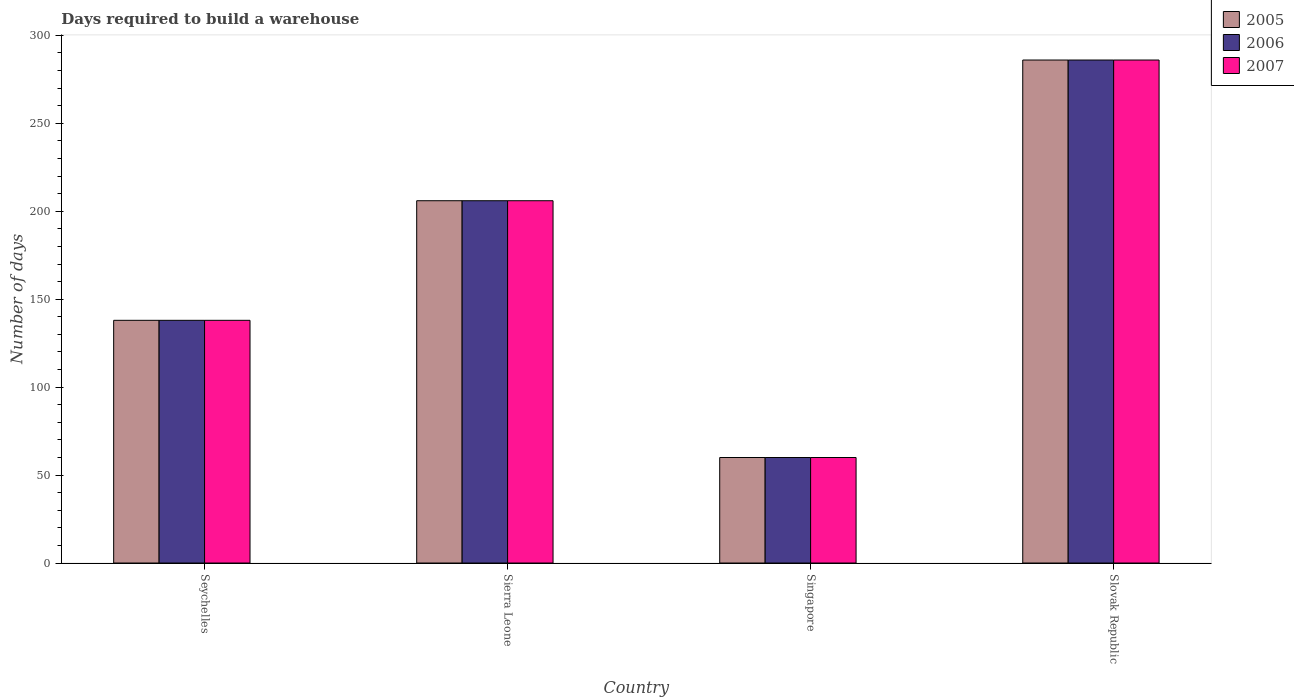How many different coloured bars are there?
Offer a very short reply. 3. Are the number of bars per tick equal to the number of legend labels?
Your answer should be very brief. Yes. What is the label of the 1st group of bars from the left?
Give a very brief answer. Seychelles. What is the days required to build a warehouse in in 2006 in Seychelles?
Your answer should be compact. 138. Across all countries, what is the maximum days required to build a warehouse in in 2007?
Make the answer very short. 286. In which country was the days required to build a warehouse in in 2007 maximum?
Make the answer very short. Slovak Republic. In which country was the days required to build a warehouse in in 2005 minimum?
Make the answer very short. Singapore. What is the total days required to build a warehouse in in 2005 in the graph?
Provide a short and direct response. 690. What is the difference between the days required to build a warehouse in in 2007 in Sierra Leone and that in Slovak Republic?
Offer a terse response. -80. What is the difference between the days required to build a warehouse in in 2006 in Slovak Republic and the days required to build a warehouse in in 2005 in Sierra Leone?
Offer a very short reply. 80. What is the average days required to build a warehouse in in 2005 per country?
Your response must be concise. 172.5. What is the difference between the days required to build a warehouse in of/in 2005 and days required to build a warehouse in of/in 2007 in Singapore?
Your response must be concise. 0. In how many countries, is the days required to build a warehouse in in 2007 greater than 180 days?
Your answer should be very brief. 2. What is the ratio of the days required to build a warehouse in in 2007 in Sierra Leone to that in Singapore?
Your answer should be very brief. 3.43. Is the days required to build a warehouse in in 2006 in Seychelles less than that in Slovak Republic?
Offer a terse response. Yes. What is the difference between the highest and the second highest days required to build a warehouse in in 2006?
Ensure brevity in your answer.  -68. What is the difference between the highest and the lowest days required to build a warehouse in in 2005?
Offer a terse response. 226. What does the 3rd bar from the left in Sierra Leone represents?
Your answer should be compact. 2007. What does the 3rd bar from the right in Sierra Leone represents?
Provide a succinct answer. 2005. Are all the bars in the graph horizontal?
Your answer should be very brief. No. What is the difference between two consecutive major ticks on the Y-axis?
Ensure brevity in your answer.  50. Does the graph contain grids?
Your response must be concise. No. Where does the legend appear in the graph?
Your response must be concise. Top right. What is the title of the graph?
Your response must be concise. Days required to build a warehouse. Does "1992" appear as one of the legend labels in the graph?
Provide a short and direct response. No. What is the label or title of the X-axis?
Make the answer very short. Country. What is the label or title of the Y-axis?
Provide a short and direct response. Number of days. What is the Number of days in 2005 in Seychelles?
Give a very brief answer. 138. What is the Number of days in 2006 in Seychelles?
Ensure brevity in your answer.  138. What is the Number of days of 2007 in Seychelles?
Your answer should be compact. 138. What is the Number of days in 2005 in Sierra Leone?
Provide a succinct answer. 206. What is the Number of days in 2006 in Sierra Leone?
Provide a succinct answer. 206. What is the Number of days of 2007 in Sierra Leone?
Offer a terse response. 206. What is the Number of days of 2005 in Singapore?
Give a very brief answer. 60. What is the Number of days of 2006 in Singapore?
Your answer should be compact. 60. What is the Number of days of 2007 in Singapore?
Your answer should be very brief. 60. What is the Number of days of 2005 in Slovak Republic?
Provide a short and direct response. 286. What is the Number of days of 2006 in Slovak Republic?
Ensure brevity in your answer.  286. What is the Number of days in 2007 in Slovak Republic?
Ensure brevity in your answer.  286. Across all countries, what is the maximum Number of days of 2005?
Make the answer very short. 286. Across all countries, what is the maximum Number of days in 2006?
Offer a very short reply. 286. Across all countries, what is the maximum Number of days in 2007?
Provide a succinct answer. 286. Across all countries, what is the minimum Number of days of 2006?
Your answer should be very brief. 60. What is the total Number of days in 2005 in the graph?
Provide a short and direct response. 690. What is the total Number of days in 2006 in the graph?
Give a very brief answer. 690. What is the total Number of days of 2007 in the graph?
Keep it short and to the point. 690. What is the difference between the Number of days of 2005 in Seychelles and that in Sierra Leone?
Offer a terse response. -68. What is the difference between the Number of days of 2006 in Seychelles and that in Sierra Leone?
Your response must be concise. -68. What is the difference between the Number of days in 2007 in Seychelles and that in Sierra Leone?
Make the answer very short. -68. What is the difference between the Number of days in 2005 in Seychelles and that in Slovak Republic?
Give a very brief answer. -148. What is the difference between the Number of days of 2006 in Seychelles and that in Slovak Republic?
Offer a terse response. -148. What is the difference between the Number of days of 2007 in Seychelles and that in Slovak Republic?
Your answer should be very brief. -148. What is the difference between the Number of days of 2005 in Sierra Leone and that in Singapore?
Your answer should be compact. 146. What is the difference between the Number of days of 2006 in Sierra Leone and that in Singapore?
Give a very brief answer. 146. What is the difference between the Number of days of 2007 in Sierra Leone and that in Singapore?
Provide a short and direct response. 146. What is the difference between the Number of days of 2005 in Sierra Leone and that in Slovak Republic?
Make the answer very short. -80. What is the difference between the Number of days in 2006 in Sierra Leone and that in Slovak Republic?
Your response must be concise. -80. What is the difference between the Number of days in 2007 in Sierra Leone and that in Slovak Republic?
Ensure brevity in your answer.  -80. What is the difference between the Number of days of 2005 in Singapore and that in Slovak Republic?
Keep it short and to the point. -226. What is the difference between the Number of days of 2006 in Singapore and that in Slovak Republic?
Make the answer very short. -226. What is the difference between the Number of days in 2007 in Singapore and that in Slovak Republic?
Your answer should be very brief. -226. What is the difference between the Number of days of 2005 in Seychelles and the Number of days of 2006 in Sierra Leone?
Provide a succinct answer. -68. What is the difference between the Number of days of 2005 in Seychelles and the Number of days of 2007 in Sierra Leone?
Your answer should be compact. -68. What is the difference between the Number of days in 2006 in Seychelles and the Number of days in 2007 in Sierra Leone?
Ensure brevity in your answer.  -68. What is the difference between the Number of days in 2006 in Seychelles and the Number of days in 2007 in Singapore?
Ensure brevity in your answer.  78. What is the difference between the Number of days of 2005 in Seychelles and the Number of days of 2006 in Slovak Republic?
Keep it short and to the point. -148. What is the difference between the Number of days of 2005 in Seychelles and the Number of days of 2007 in Slovak Republic?
Make the answer very short. -148. What is the difference between the Number of days in 2006 in Seychelles and the Number of days in 2007 in Slovak Republic?
Offer a terse response. -148. What is the difference between the Number of days of 2005 in Sierra Leone and the Number of days of 2006 in Singapore?
Offer a terse response. 146. What is the difference between the Number of days in 2005 in Sierra Leone and the Number of days in 2007 in Singapore?
Give a very brief answer. 146. What is the difference between the Number of days in 2006 in Sierra Leone and the Number of days in 2007 in Singapore?
Offer a terse response. 146. What is the difference between the Number of days in 2005 in Sierra Leone and the Number of days in 2006 in Slovak Republic?
Keep it short and to the point. -80. What is the difference between the Number of days in 2005 in Sierra Leone and the Number of days in 2007 in Slovak Republic?
Keep it short and to the point. -80. What is the difference between the Number of days in 2006 in Sierra Leone and the Number of days in 2007 in Slovak Republic?
Keep it short and to the point. -80. What is the difference between the Number of days of 2005 in Singapore and the Number of days of 2006 in Slovak Republic?
Your answer should be compact. -226. What is the difference between the Number of days of 2005 in Singapore and the Number of days of 2007 in Slovak Republic?
Give a very brief answer. -226. What is the difference between the Number of days of 2006 in Singapore and the Number of days of 2007 in Slovak Republic?
Keep it short and to the point. -226. What is the average Number of days of 2005 per country?
Your answer should be very brief. 172.5. What is the average Number of days of 2006 per country?
Your response must be concise. 172.5. What is the average Number of days in 2007 per country?
Your response must be concise. 172.5. What is the difference between the Number of days of 2005 and Number of days of 2007 in Seychelles?
Your answer should be compact. 0. What is the difference between the Number of days in 2005 and Number of days in 2006 in Sierra Leone?
Keep it short and to the point. 0. What is the difference between the Number of days of 2005 and Number of days of 2007 in Sierra Leone?
Offer a terse response. 0. What is the difference between the Number of days of 2005 and Number of days of 2006 in Singapore?
Your response must be concise. 0. What is the difference between the Number of days in 2005 and Number of days in 2007 in Singapore?
Offer a terse response. 0. What is the difference between the Number of days of 2006 and Number of days of 2007 in Slovak Republic?
Your answer should be very brief. 0. What is the ratio of the Number of days in 2005 in Seychelles to that in Sierra Leone?
Your answer should be compact. 0.67. What is the ratio of the Number of days in 2006 in Seychelles to that in Sierra Leone?
Keep it short and to the point. 0.67. What is the ratio of the Number of days in 2007 in Seychelles to that in Sierra Leone?
Provide a succinct answer. 0.67. What is the ratio of the Number of days of 2007 in Seychelles to that in Singapore?
Provide a succinct answer. 2.3. What is the ratio of the Number of days in 2005 in Seychelles to that in Slovak Republic?
Give a very brief answer. 0.48. What is the ratio of the Number of days of 2006 in Seychelles to that in Slovak Republic?
Offer a terse response. 0.48. What is the ratio of the Number of days in 2007 in Seychelles to that in Slovak Republic?
Ensure brevity in your answer.  0.48. What is the ratio of the Number of days of 2005 in Sierra Leone to that in Singapore?
Your response must be concise. 3.43. What is the ratio of the Number of days of 2006 in Sierra Leone to that in Singapore?
Provide a succinct answer. 3.43. What is the ratio of the Number of days in 2007 in Sierra Leone to that in Singapore?
Provide a short and direct response. 3.43. What is the ratio of the Number of days of 2005 in Sierra Leone to that in Slovak Republic?
Make the answer very short. 0.72. What is the ratio of the Number of days in 2006 in Sierra Leone to that in Slovak Republic?
Give a very brief answer. 0.72. What is the ratio of the Number of days in 2007 in Sierra Leone to that in Slovak Republic?
Make the answer very short. 0.72. What is the ratio of the Number of days of 2005 in Singapore to that in Slovak Republic?
Your answer should be compact. 0.21. What is the ratio of the Number of days in 2006 in Singapore to that in Slovak Republic?
Offer a terse response. 0.21. What is the ratio of the Number of days in 2007 in Singapore to that in Slovak Republic?
Make the answer very short. 0.21. What is the difference between the highest and the second highest Number of days in 2005?
Give a very brief answer. 80. What is the difference between the highest and the second highest Number of days of 2006?
Your response must be concise. 80. What is the difference between the highest and the lowest Number of days of 2005?
Provide a succinct answer. 226. What is the difference between the highest and the lowest Number of days of 2006?
Provide a short and direct response. 226. What is the difference between the highest and the lowest Number of days in 2007?
Your response must be concise. 226. 